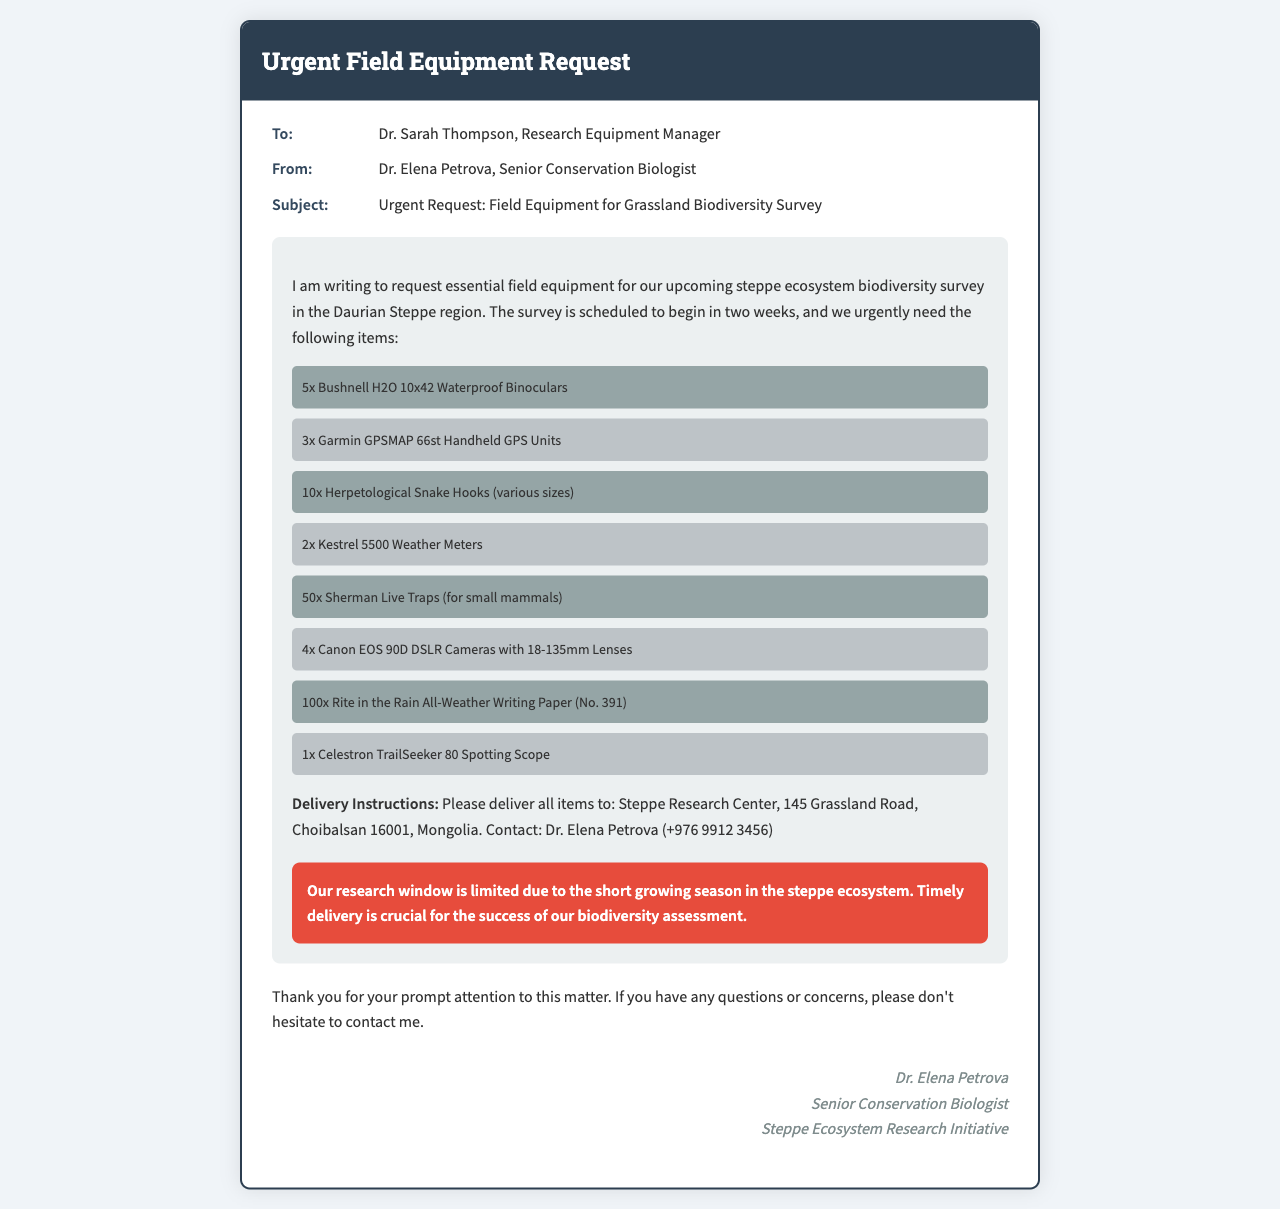What is the name of the sender? The sender of the fax is identified in the "From" section as Dr. Elena Petrova.
Answer: Dr. Elena Petrova Who is the recipient of the fax? The recipient is identified in the "To" section as Dr. Sarah Thompson.
Answer: Dr. Sarah Thompson How many Canon EOS 90D DSLR Cameras are requested? The document lists the quantity of Canon EOS 90D DSLR Cameras needed in the equipment list.
Answer: 4 What is the delivery address for the equipment? The delivery instructions explicitly mention the destination address for the equipment.
Answer: Steppe Research Center, 145 Grassland Road, Choibalsan 16001, Mongolia What is the urgency note's main message? The urgency note emphasizes the importance of timely delivery for research due to ecological factors stated in the document.
Answer: Timely delivery is crucial for the success of our biodiversity assessment How many different types of GPS units are requested? The equipment list specifies the quantity and type of GPS units needed, in this case, Garmin GPSMAP 66st Handheld GPS Units.
Answer: 3 What is the main purpose of the equipment request? The document outlines the purpose of the field equipment request related to a specific research survey in the Daurian Steppe region.
Answer: Grassland biodiversity survey What is the number of Sherman Live Traps requested? The document specifies the quantity of Sherman Live Traps required for the survey.
Answer: 50 Who should be contacted in case of questions? The contact information is provided under the delivery instructions, specifying who should be contacted and their phone number.
Answer: Dr. Elena Petrova (+976 9912 3456) 